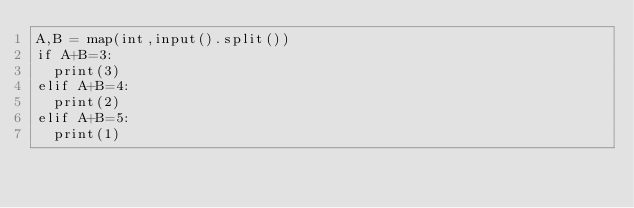<code> <loc_0><loc_0><loc_500><loc_500><_Python_>A,B = map(int,input().split())
if A+B=3:
  print(3)
elif A+B=4:
  print(2)
elif A+B=5:
  print(1)</code> 